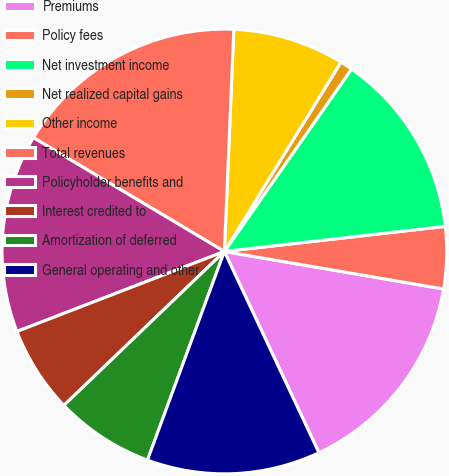Convert chart. <chart><loc_0><loc_0><loc_500><loc_500><pie_chart><fcel>Premiums<fcel>Policy fees<fcel>Net investment income<fcel>Net realized capital gains<fcel>Other income<fcel>Total revenues<fcel>Policyholder benefits and<fcel>Interest credited to<fcel>Amortization of deferred<fcel>General operating and other<nl><fcel>15.31%<fcel>4.5%<fcel>13.51%<fcel>0.9%<fcel>8.11%<fcel>17.12%<fcel>14.41%<fcel>6.31%<fcel>7.21%<fcel>12.61%<nl></chart> 